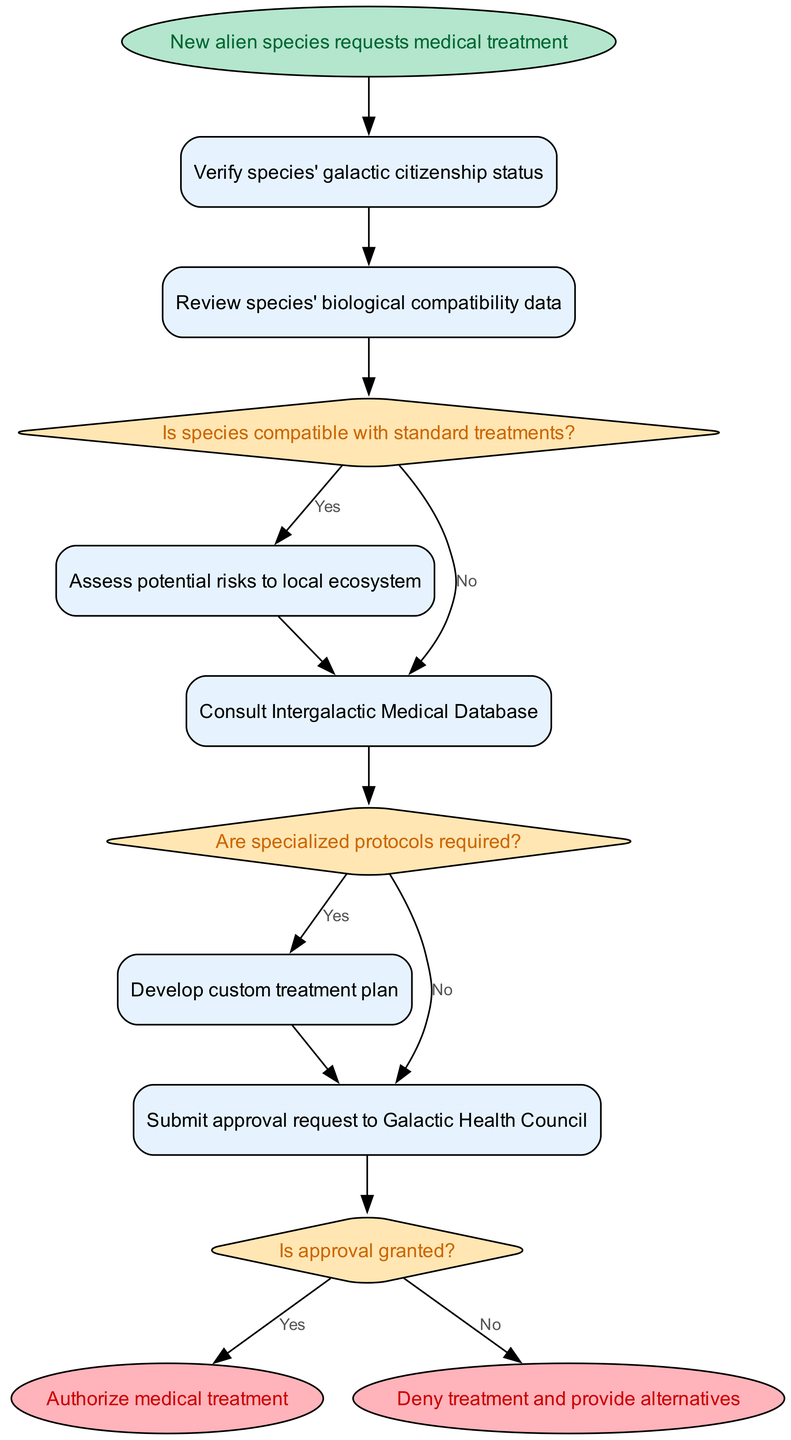What is the first step in the protocol? The first step in the protocol is to verify the species' galactic citizenship status. This is indicated by the flow starting from "New alien species requests medical treatment" leading to "Verify species' galactic citizenship status".
Answer: Verify species' galactic citizenship status What happens after reviewing biological compatibility data? After reviewing the biological compatibility data, the next action depends on the compatibility of the species with standard treatments. If they are compatible, it leads to assessing potential risks to the local ecosystem; if not, it leads to consulting the Intergalactic Medical Database.
Answer: Assess potential risks to local ecosystem or Consult Intergalactic Medical Database How many decision points are in this diagram? The diagram contains three decision points: "Is species compatible with standard treatments?", "Are specialized protocols required?", and "Is approval granted?". Counting these from the diagram gives a total of three.
Answer: 3 What is the outcome if approval is not granted? If approval is not granted, the final outcome is to deny treatment and provide alternatives, as indicated in the flow chart. This is shown at the end of the flow leading from "Is approval granted?" to "Deny treatment and provide alternatives".
Answer: Deny treatment and provide alternatives What is the last step when the treatment is approved? The last step when the treatment is approved is to authorize medical treatment. This is represented by the end node "Authorize medical treatment" that follows after the decision point "Is approval granted?" leading to "Yes".
Answer: Authorize medical treatment What step must be completed before submitting the approval request? Before submitting the approval request to the Galactic Health Council, a custom treatment plan must be developed if specialized protocols are required. This flow can be followed from the decision "Are specialized protocols required?" leading to "Develop custom treatment plan".
Answer: Develop custom treatment plan What step follows after assessing potential risks? After assessing potential risks to the local ecosystem, the next step is to consult the Intergalactic Medical Database, following the path from "Assess potential risks to local ecosystem" to "Consult Intergalactic Medical Database".
Answer: Consult Intergalactic Medical Database If the species is not compatible with standard treatments, what is the next action? If the species is not compatible with standard treatments, the next action is to consult the Intergalactic Medical Database. This is depicted in the diagram under the decision point "Is species compatible with standard treatments?" leading to "No".
Answer: Consult Intergalactic Medical Database 